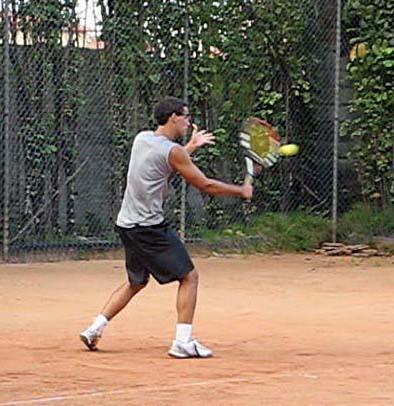How many cows are there?
Give a very brief answer. 0. 